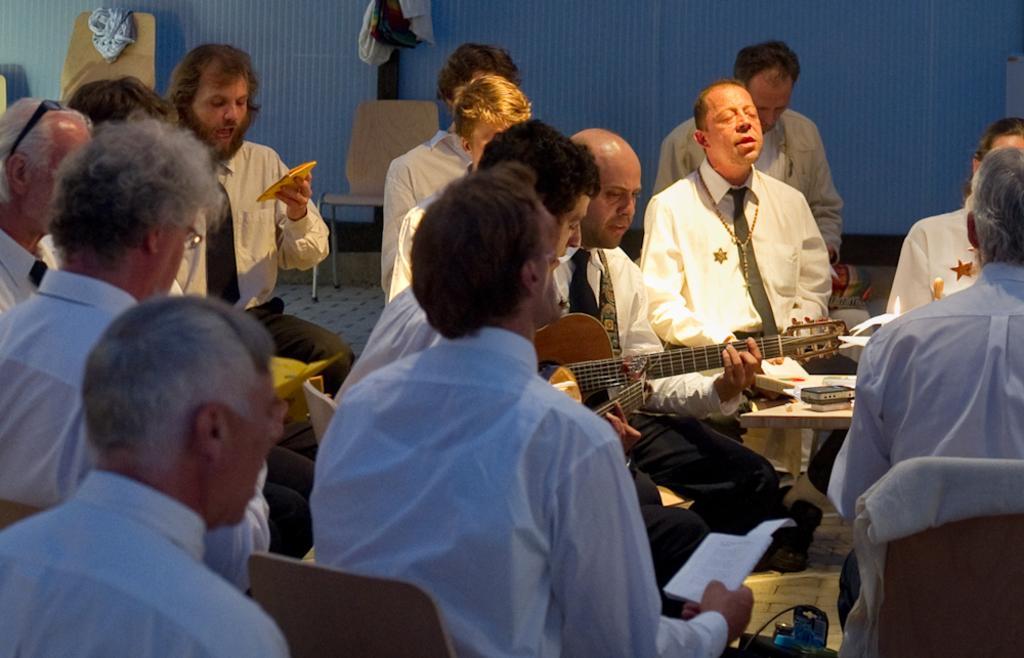Please provide a concise description of this image. In this image we can see a few people who are sitting and they are praying. Here we can see a person sitting on a chair and he is playing a guitar. 